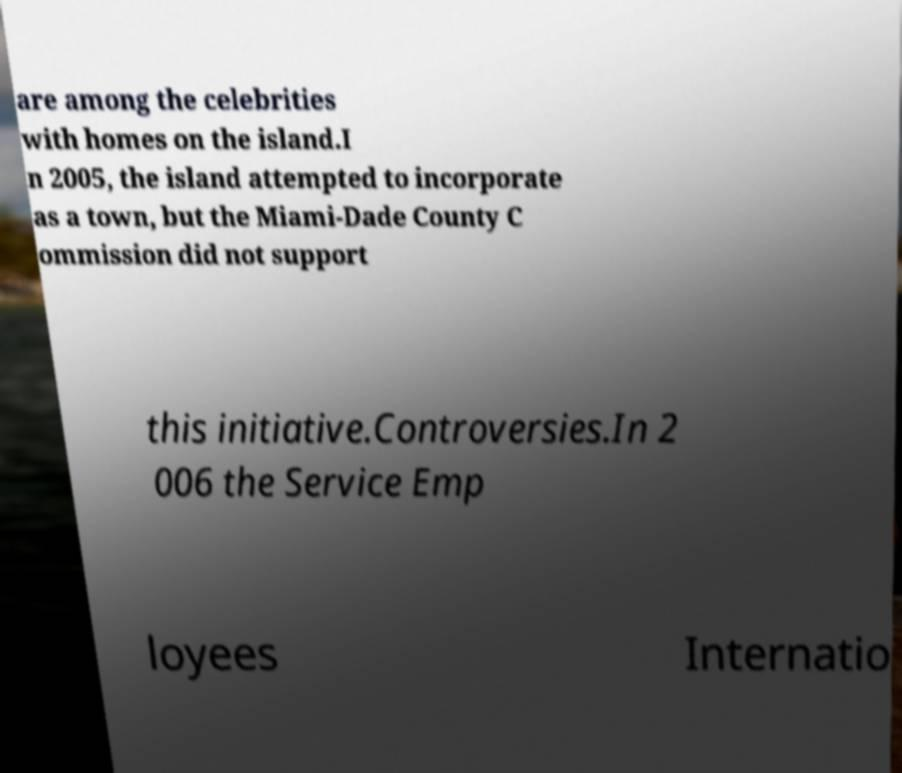There's text embedded in this image that I need extracted. Can you transcribe it verbatim? are among the celebrities with homes on the island.I n 2005, the island attempted to incorporate as a town, but the Miami-Dade County C ommission did not support this initiative.Controversies.In 2 006 the Service Emp loyees Internatio 